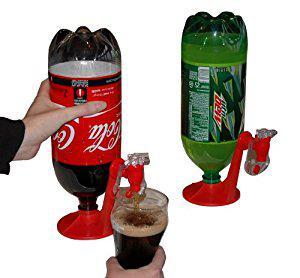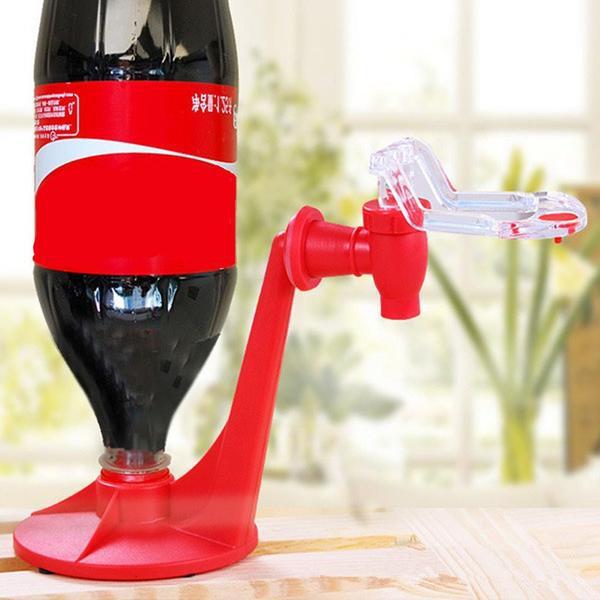The first image is the image on the left, the second image is the image on the right. Evaluate the accuracy of this statement regarding the images: "One of the soda bottles is green.". Is it true? Answer yes or no. Yes. 